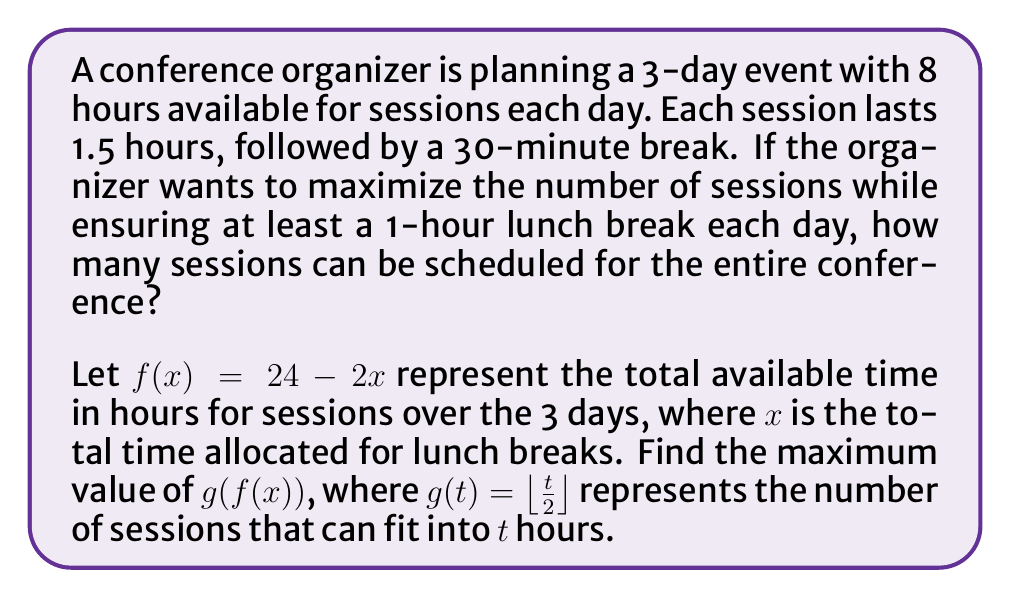Solve this math problem. Let's approach this step-by-step:

1) First, we need to understand what $f(x)$ and $g(t)$ represent:
   - $f(x) = 24 - 2x$ is the total available time for sessions in hours
   - $g(t) = \lfloor \frac{t}{2} \rfloor$ is the number of sessions that can fit into $t$ hours

2) We know that each day has a minimum 1-hour lunch break, so $x \geq 3$ (1 hour per day for 3 days).

3) The maximum value of $x$ is 4.5 hours (1.5 hours per day), as this leaves exactly 24 - 2(4.5) = 15 hours for sessions.

4) Now, let's consider $g(f(x))$:
   $g(f(x)) = \lfloor \frac{24 - 2x}{2} \rfloor = \lfloor 12 - x \rfloor$

5) To maximize $g(f(x))$, we need to minimize $x$ while keeping it $\geq 3$.
   The minimum value of $x$ is 3, so the maximum value of $g(f(x))$ is:
   $g(f(3)) = \lfloor 12 - 3 \rfloor = \lfloor 9 \rfloor = 9$

6) This means we can fit 9 sessions into the conference.

7) To verify:
   - 9 sessions * 1.5 hours per session = 13.5 hours for sessions
   - 8 breaks * 0.5 hours per break = 4 hours for breaks
   - 3 days * 1 hour lunch per day = 3 hours for lunch
   Total: 13.5 + 4 + 3 = 20.5 hours, which fits within the 24 hours available
Answer: 9 sessions 